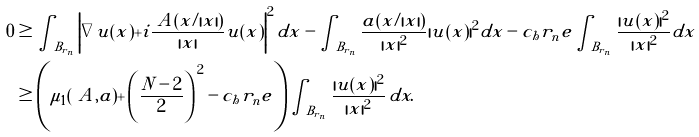<formula> <loc_0><loc_0><loc_500><loc_500>0 & \geq \int _ { B _ { r _ { n } } } \left | \nabla u ( x ) + i \frac { \ A ( x / | x | ) } { | x | } u ( x ) \right | ^ { 2 } d x - \int _ { B _ { r _ { n } } } \frac { a ( x / | x | ) } { | x | ^ { 2 } } | u ( x ) | ^ { 2 } d x - c _ { h } r _ { n } ^ { \ } e \int _ { B _ { r _ { n } } } \frac { | u ( x ) | ^ { 2 } } { | x | ^ { 2 } } d x \\ & \geq \left ( \mu _ { 1 } ( \ A , a ) + \left ( \frac { N - 2 } { 2 } \right ) ^ { \, 2 } - c _ { h } r _ { n } ^ { \ } e \right ) \int _ { B _ { r _ { n } } } \frac { | u ( x ) | ^ { 2 } } { | x | ^ { 2 } } \, d x .</formula> 